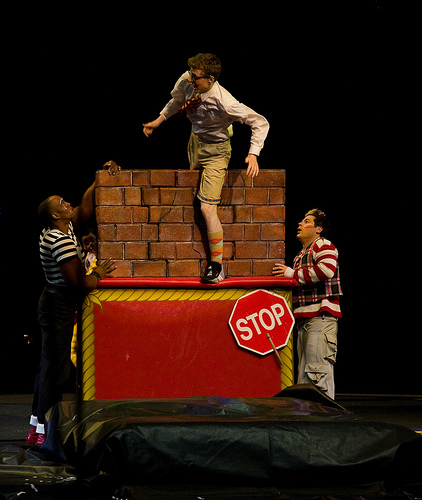<image>
Can you confirm if the person is behind the wall? Yes. From this viewpoint, the person is positioned behind the wall, with the wall partially or fully occluding the person. Where is the sign in relation to the wall? Is it in front of the wall? Yes. The sign is positioned in front of the wall, appearing closer to the camera viewpoint. 